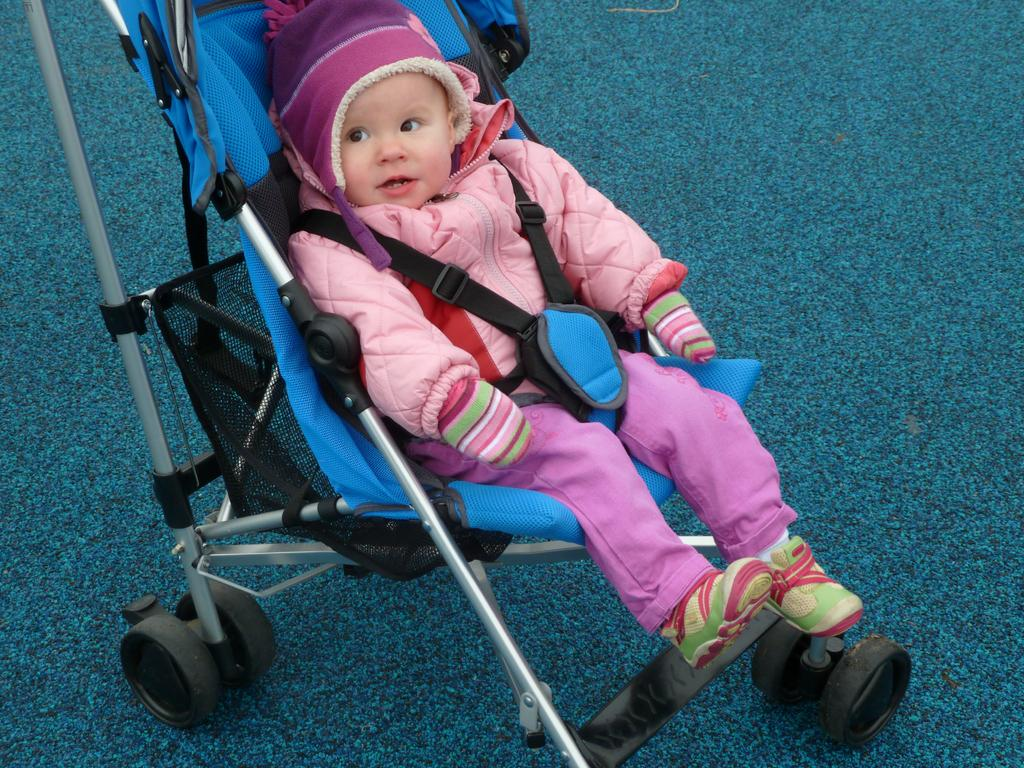What is the main subject of the image? There is a baby in the image. What is the baby sitting on? The baby is sitting on a baby chair. What type of clothing is the baby wearing? The baby is wearing a jacket, gloves, and a cap. What color is the background of the image? The background of the image is blue. Can you hear the bells ringing in the image? There are no bells present in the image, so it is not possible to hear them ringing. 